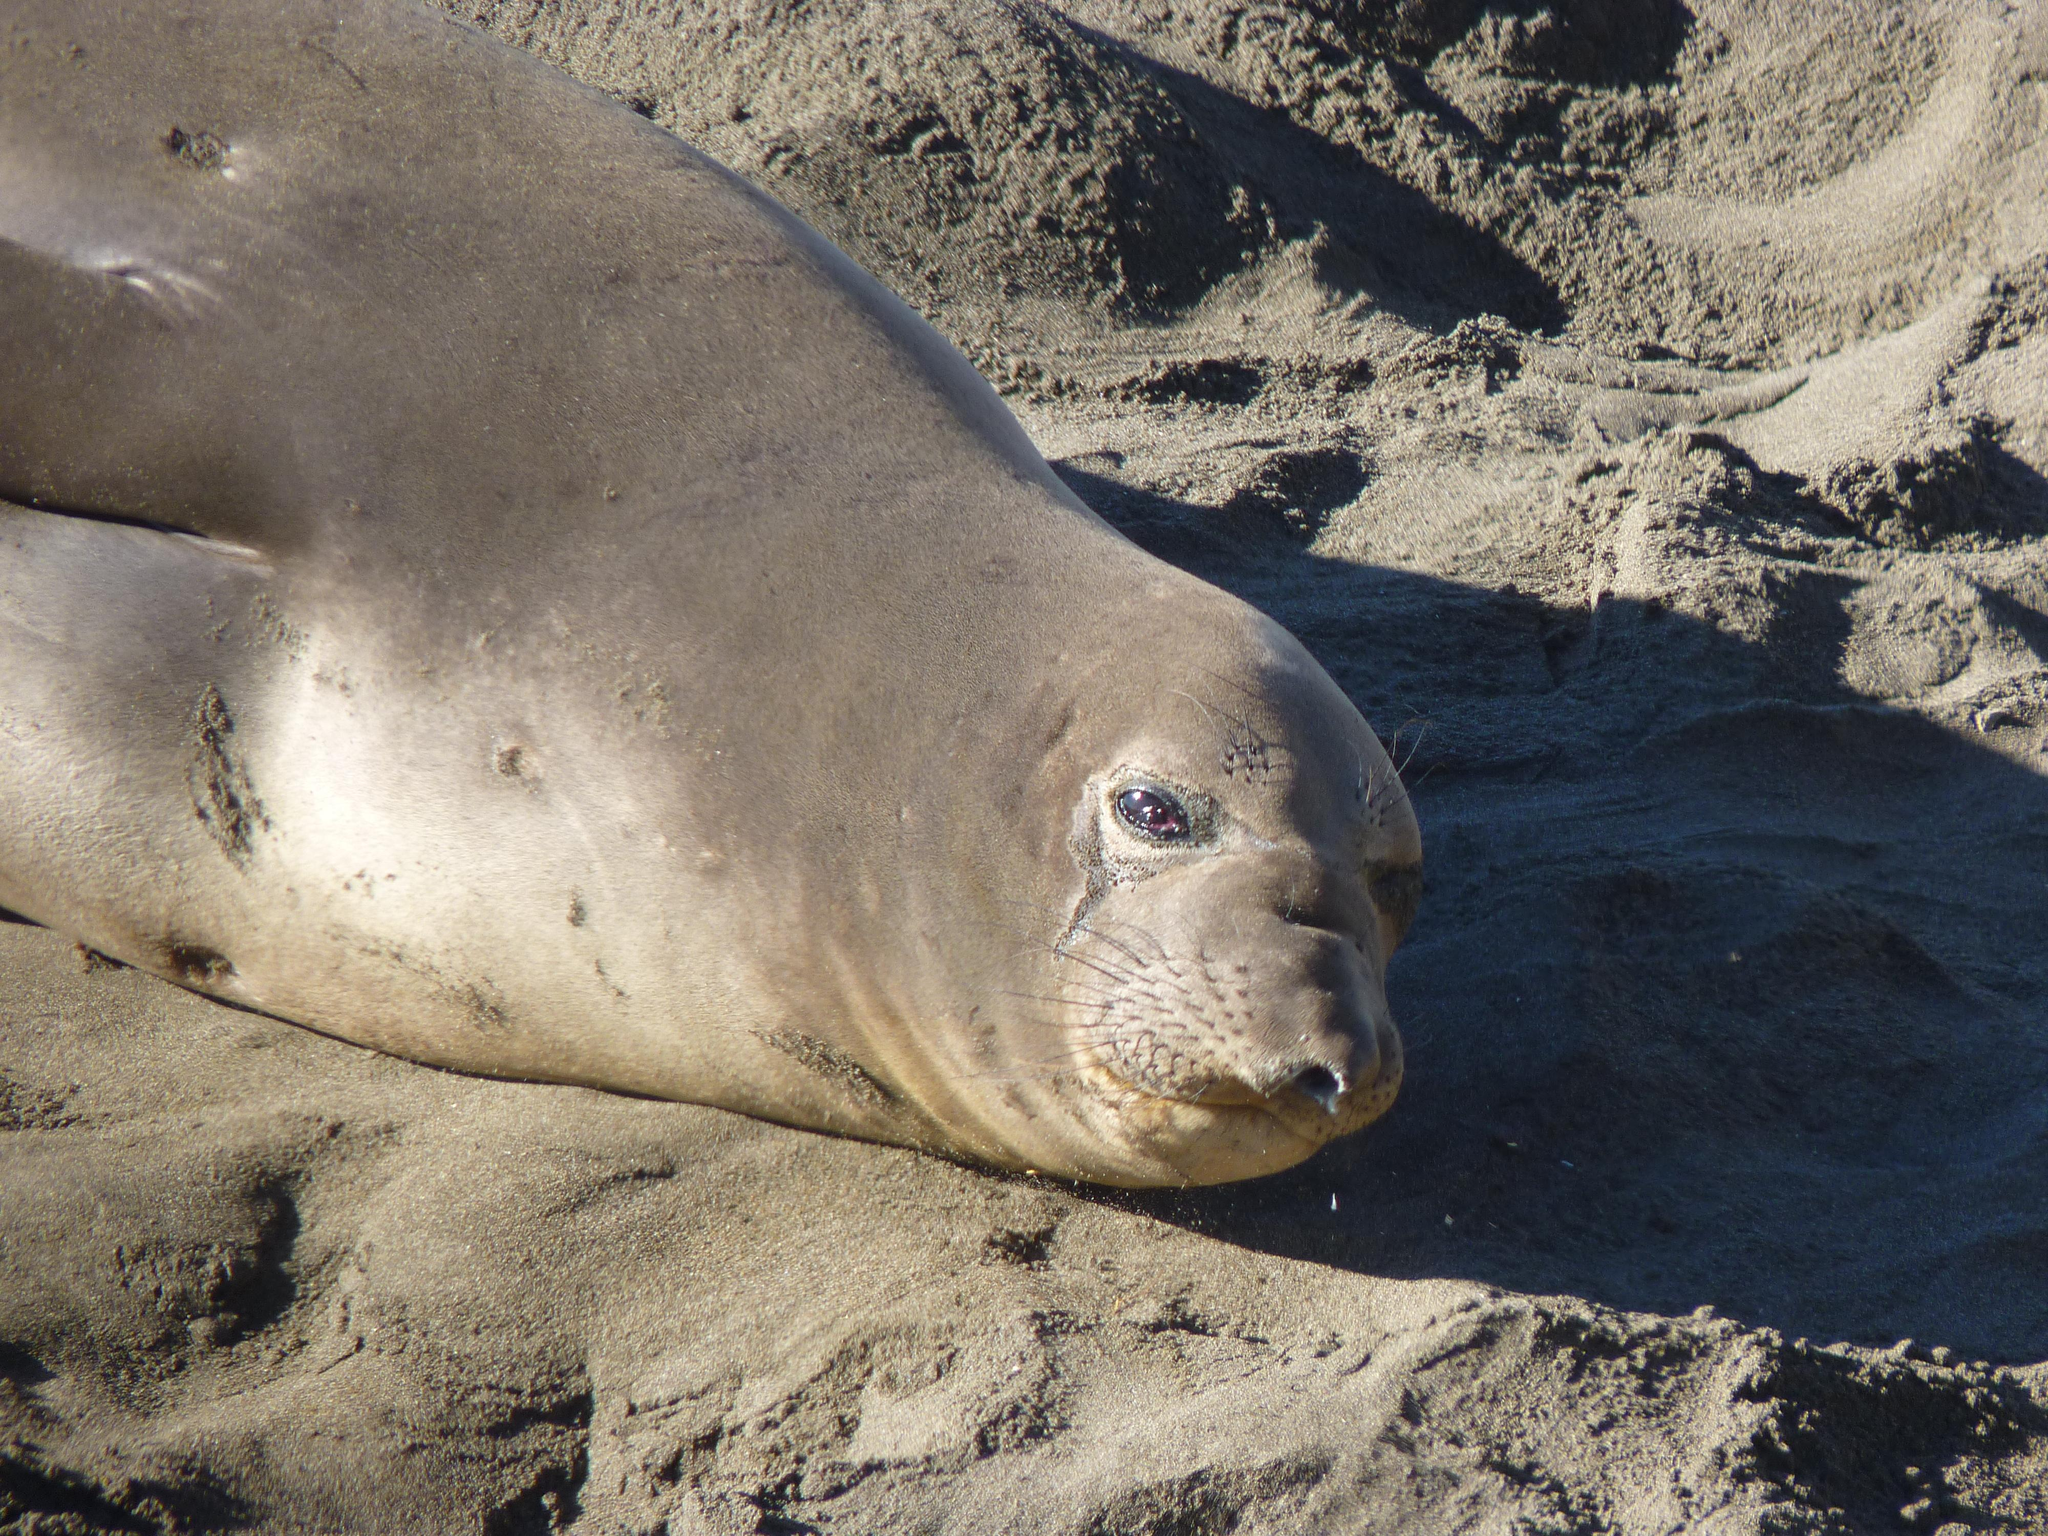What animal can be seen on the ground in the image? There is a seal on the ground in the image. Can you tell me how many cubs are playing with the seal in the image? There are no cubs present in the image; it only features a seal on the ground. What is the stomach of the seal doing in the image? There is no specific focus on the stomach of the seal in the image; it is simply a picture of a seal lying on the ground. 